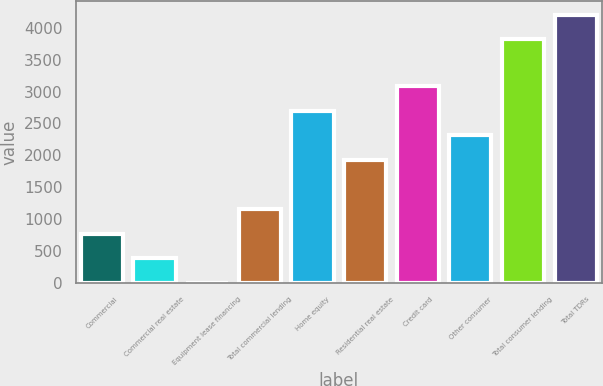<chart> <loc_0><loc_0><loc_500><loc_500><bar_chart><fcel>Commercial<fcel>Commercial real estate<fcel>Equipment lease financing<fcel>Total commercial lending<fcel>Home equity<fcel>Residential real estate<fcel>Credit card<fcel>Other consumer<fcel>Total consumer lending<fcel>Total TDRs<nl><fcel>772.2<fcel>386.6<fcel>1<fcel>1157.8<fcel>2700.2<fcel>1929<fcel>3085.8<fcel>2314.6<fcel>3820<fcel>4205.6<nl></chart> 